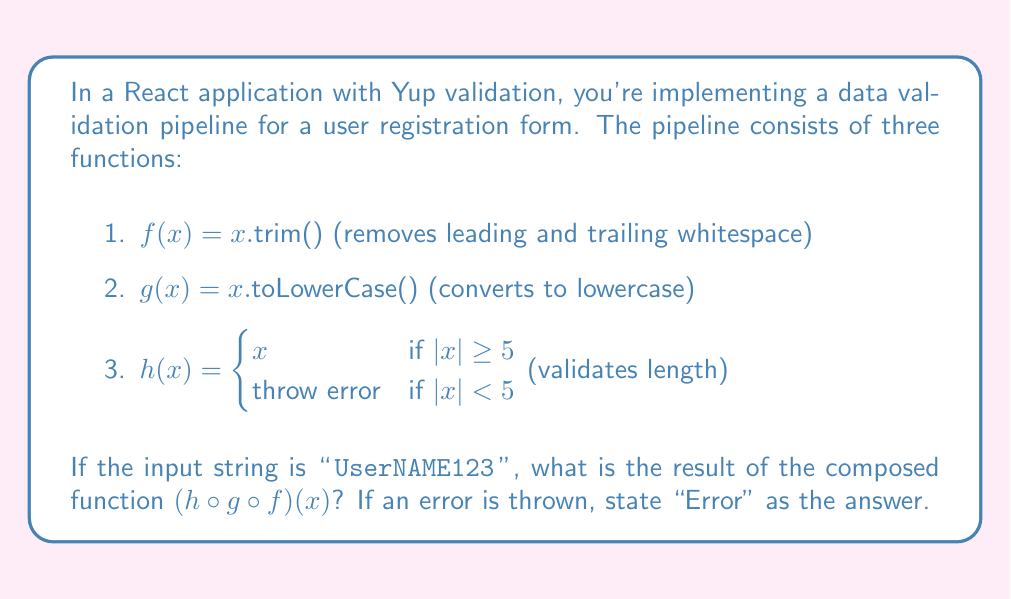Solve this math problem. Let's break down the problem step-by-step:

1. First, we apply function $f$ to remove leading and trailing whitespace:
   $f(" UserNAME123 ") = \text{"UserNAME123"}$

2. Next, we apply function $g$ to convert the result to lowercase:
   $g(\text{"UserNAME123"}) = \text{"username123"}$

3. Finally, we apply function $h$ to validate the length:
   $h(\text{"username123"})$

   We need to check if $|\text{"username123"}| \geq 5$:
   $|\text{"username123"}| = 11$, which is indeed $\geq 5$

   Therefore, $h(\text{"username123"}) = \text{"username123"}$

The composition $(h \circ g \circ f)(x)$ is equivalent to $h(g(f(x)))$, which we've calculated above.
Answer: "username123" 